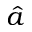Convert formula to latex. <formula><loc_0><loc_0><loc_500><loc_500>\hat { a }</formula> 